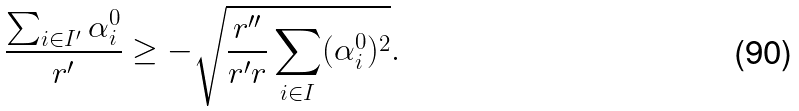Convert formula to latex. <formula><loc_0><loc_0><loc_500><loc_500>\frac { \sum _ { i \in I ^ { \prime } } \alpha ^ { 0 } _ { i } } { r ^ { \prime } } \geq - \sqrt { \frac { r ^ { \prime \prime } } { r ^ { \prime } r } \sum _ { i \in I } ( \alpha ^ { 0 } _ { i } ) ^ { 2 } } .</formula> 